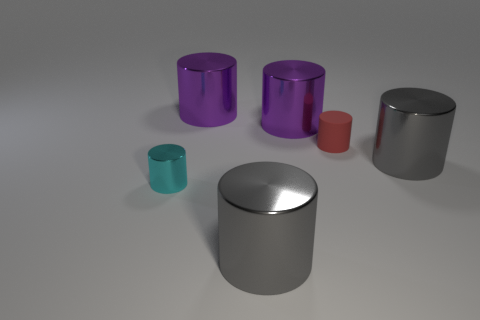Subtract all gray cylinders. How many cylinders are left? 4 Subtract all tiny cylinders. How many cylinders are left? 4 Subtract 1 cylinders. How many cylinders are left? 5 Subtract all cyan cylinders. Subtract all purple cubes. How many cylinders are left? 5 Add 1 big green metallic cubes. How many objects exist? 7 Subtract all large cyan matte blocks. Subtract all red rubber objects. How many objects are left? 5 Add 1 gray cylinders. How many gray cylinders are left? 3 Add 6 large gray things. How many large gray things exist? 8 Subtract 1 gray cylinders. How many objects are left? 5 